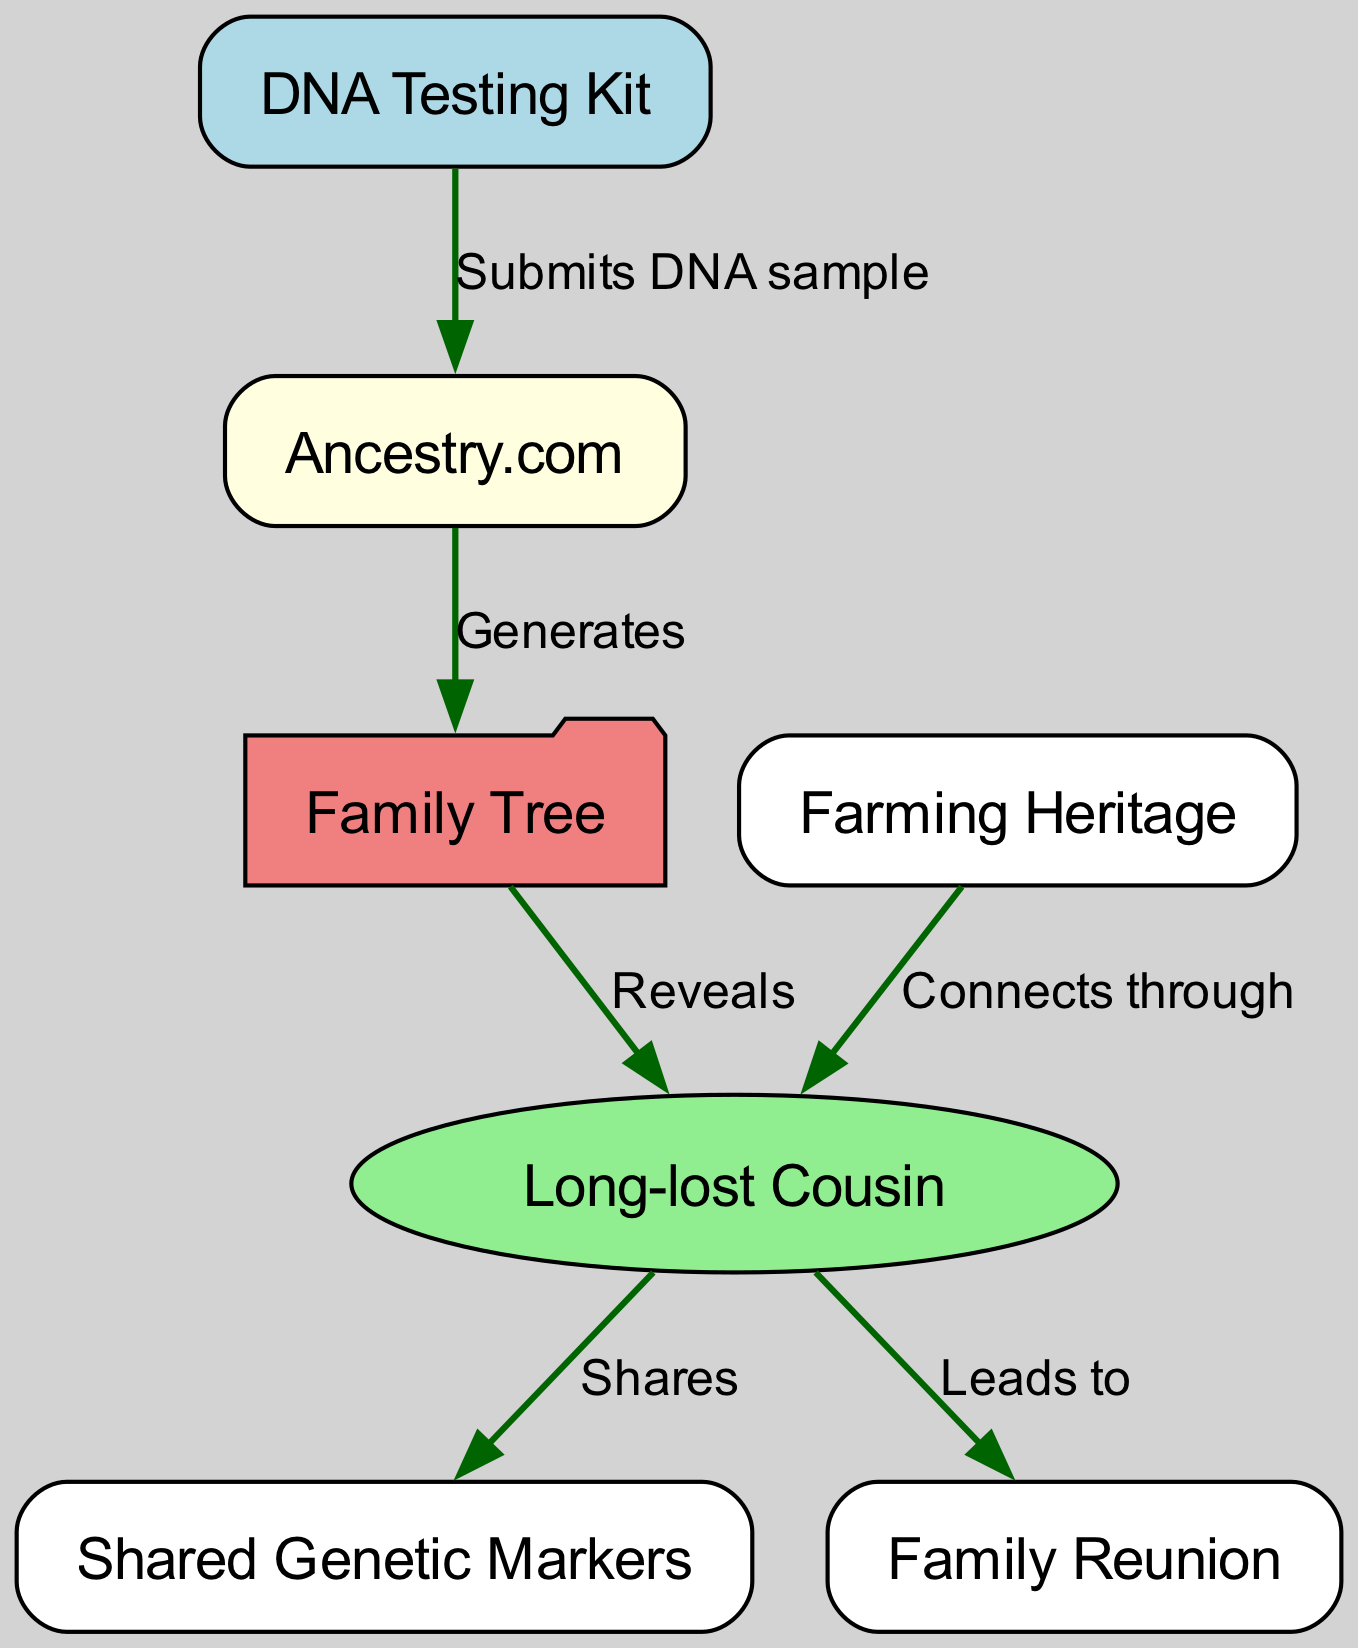What node reveals the long-lost cousin? The edge labeled "Reveals" connects the Family Tree node to the Long-lost Cousin node, indicating that the Family Tree reveals the long-lost cousin.
Answer: Long-lost Cousin How many nodes are there in the diagram? The diagram lists a total of 6 unique nodes: DNA Testing Kit, Ancestry.com, Family Tree, Long-lost Cousin, Shared Genetic Markers, Farming Heritage, and Family Reunion.
Answer: 6 What does DNA Testing Kit submit? The edge labeled "Submits DNA sample" indicates that the DNA Testing Kit submits a DNA sample to Ancestry.com.
Answer: DNA sample What relationship does farming heritage have with the long-lost cousin? The edge labeled "Connects through" indicates that Farming Heritage connects specifically to the Long-lost Cousin, implying a shared background or commonality.
Answer: Connects through Which node leads to a family reunion? The edge labeled "Leads to" going from the Long-lost Cousin node indicates that this node results in a Family Reunion.
Answer: Family Reunion Who shares genetic markers with the long-lost cousin? The edge labeled "Shares" indicates a direct relationship where the Long-lost Cousin shares Shared Genetic Markers with a relative or ancestor.
Answer: Shared Genetic Markers What service generates the family tree? The edge labeled "Generates" indicates that Ancestry.com produces the Family Tree based on the submitted data from the DNA Testing Kit.
Answer: Ancestry.com How does Farming Heritage relate to the long-lost cousin? The edge states that Farming Heritage connects through the Long-lost Cousin, suggesting that both share a historical context or lineage in farming.
Answer: Connects through What is the color of the long-lost cousin node? In the diagram, the Long-lost Cousin is represented by an ellipse filled with light green color.
Answer: Light green 